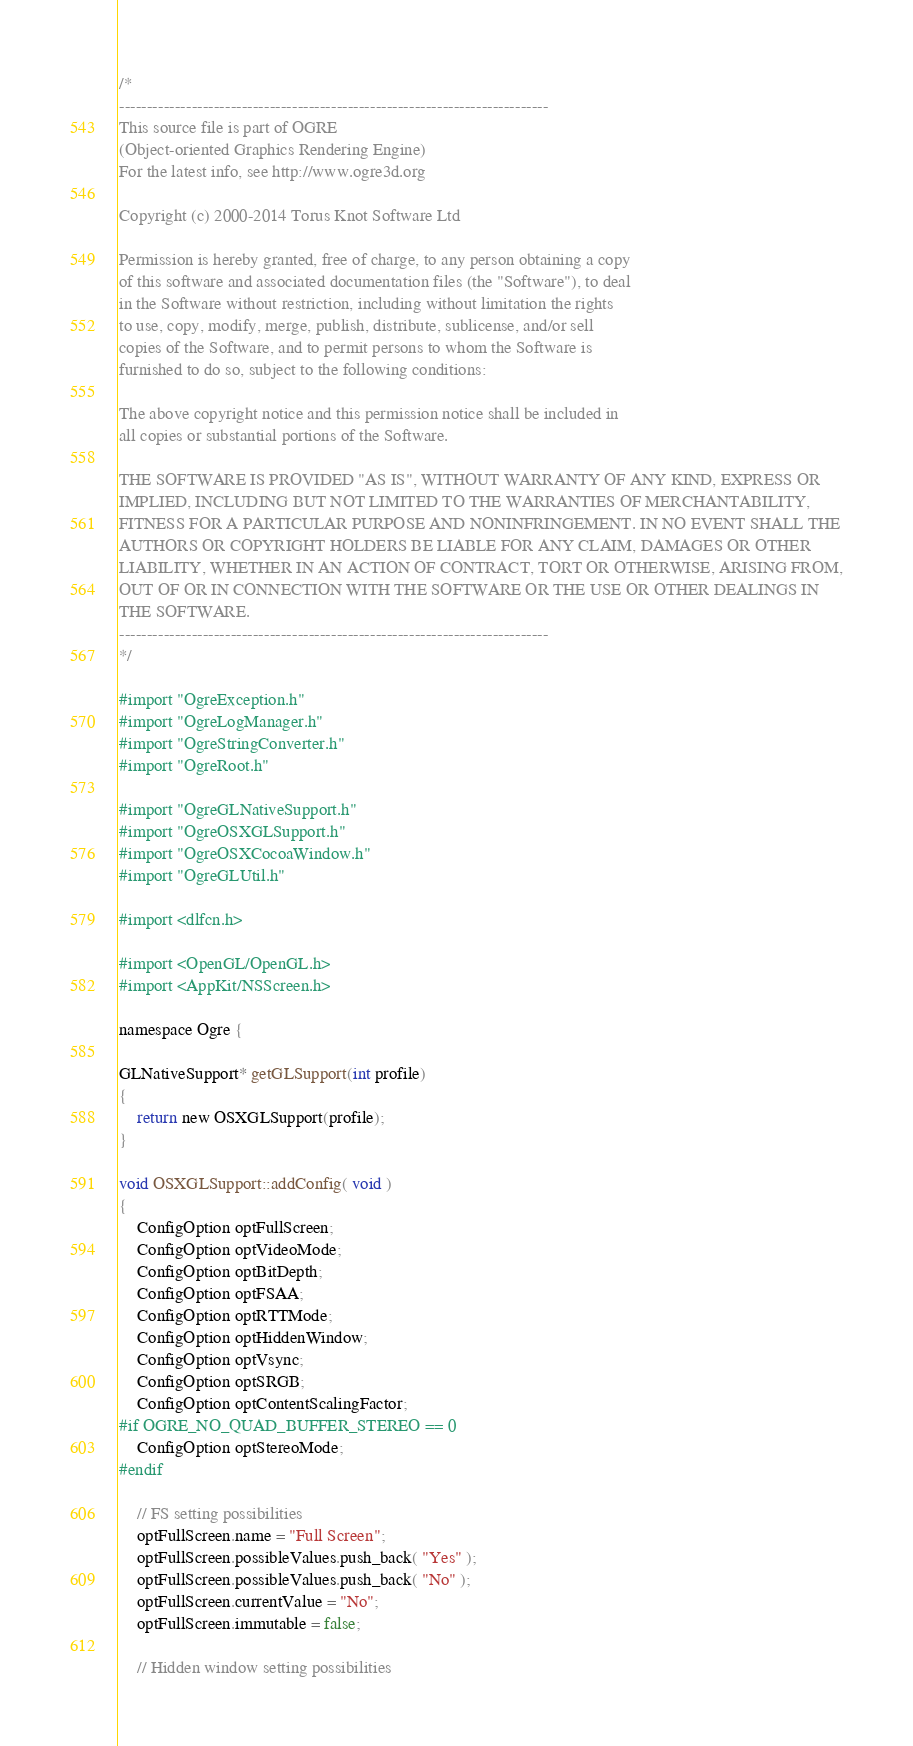Convert code to text. <code><loc_0><loc_0><loc_500><loc_500><_ObjectiveC_>/*
-----------------------------------------------------------------------------
This source file is part of OGRE
(Object-oriented Graphics Rendering Engine)
For the latest info, see http://www.ogre3d.org

Copyright (c) 2000-2014 Torus Knot Software Ltd

Permission is hereby granted, free of charge, to any person obtaining a copy
of this software and associated documentation files (the "Software"), to deal
in the Software without restriction, including without limitation the rights
to use, copy, modify, merge, publish, distribute, sublicense, and/or sell
copies of the Software, and to permit persons to whom the Software is
furnished to do so, subject to the following conditions:

The above copyright notice and this permission notice shall be included in
all copies or substantial portions of the Software.

THE SOFTWARE IS PROVIDED "AS IS", WITHOUT WARRANTY OF ANY KIND, EXPRESS OR
IMPLIED, INCLUDING BUT NOT LIMITED TO THE WARRANTIES OF MERCHANTABILITY,
FITNESS FOR A PARTICULAR PURPOSE AND NONINFRINGEMENT. IN NO EVENT SHALL THE
AUTHORS OR COPYRIGHT HOLDERS BE LIABLE FOR ANY CLAIM, DAMAGES OR OTHER
LIABILITY, WHETHER IN AN ACTION OF CONTRACT, TORT OR OTHERWISE, ARISING FROM,
OUT OF OR IN CONNECTION WITH THE SOFTWARE OR THE USE OR OTHER DEALINGS IN
THE SOFTWARE.
-----------------------------------------------------------------------------
*/

#import "OgreException.h"
#import "OgreLogManager.h"
#import "OgreStringConverter.h"
#import "OgreRoot.h"

#import "OgreGLNativeSupport.h"
#import "OgreOSXGLSupport.h"
#import "OgreOSXCocoaWindow.h"
#import "OgreGLUtil.h"

#import <dlfcn.h>

#import <OpenGL/OpenGL.h>
#import <AppKit/NSScreen.h>

namespace Ogre {

GLNativeSupport* getGLSupport(int profile)
{
    return new OSXGLSupport(profile);
}

void OSXGLSupport::addConfig( void )
{
	ConfigOption optFullScreen;
	ConfigOption optVideoMode;
	ConfigOption optBitDepth;
	ConfigOption optFSAA;
	ConfigOption optRTTMode;
	ConfigOption optHiddenWindow;
	ConfigOption optVsync;
	ConfigOption optSRGB;
    ConfigOption optContentScalingFactor;
#if OGRE_NO_QUAD_BUFFER_STEREO == 0
	ConfigOption optStereoMode;
#endif

	// FS setting possibilities
	optFullScreen.name = "Full Screen";
	optFullScreen.possibleValues.push_back( "Yes" );
	optFullScreen.possibleValues.push_back( "No" );
	optFullScreen.currentValue = "No";
	optFullScreen.immutable = false;

    // Hidden window setting possibilities</code> 